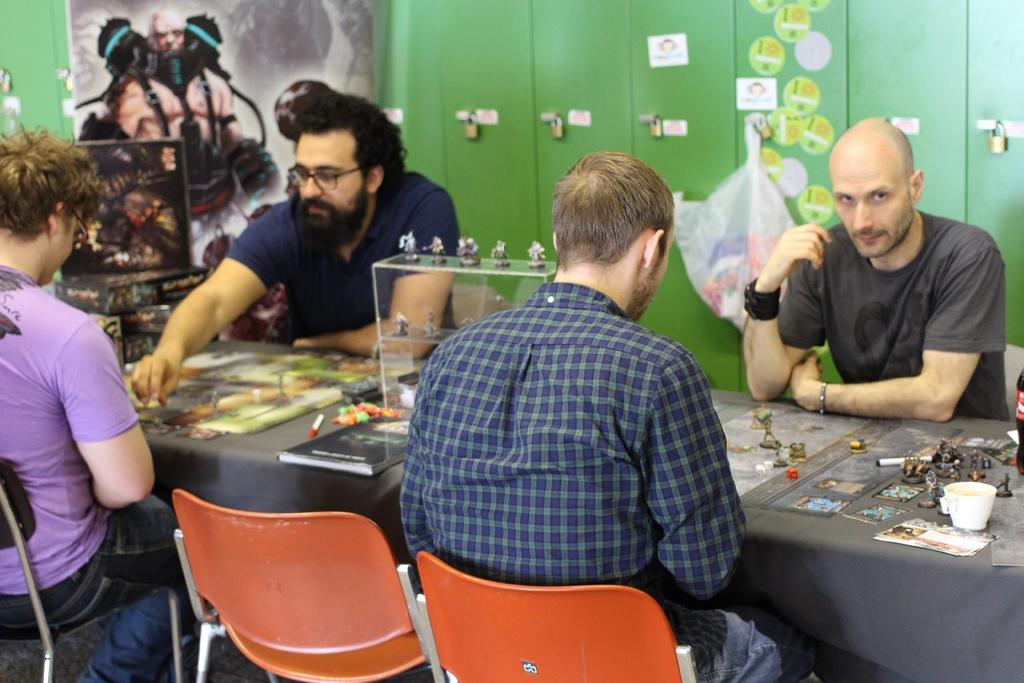How many people are present in the image? There are four people in the image. What are the people doing in the image? The people are seated on chairs and playing a game on a table. What can be seen on the wall in the image? There are posters on the wall. What type of rainstorm is depicted in the image? There is no rainstorm present in the image; it features four people playing a game on chairs with posters on the wall. What boundary is being crossed by the people in the image? There is no boundary being crossed in the image; the people are seated and playing a game. 